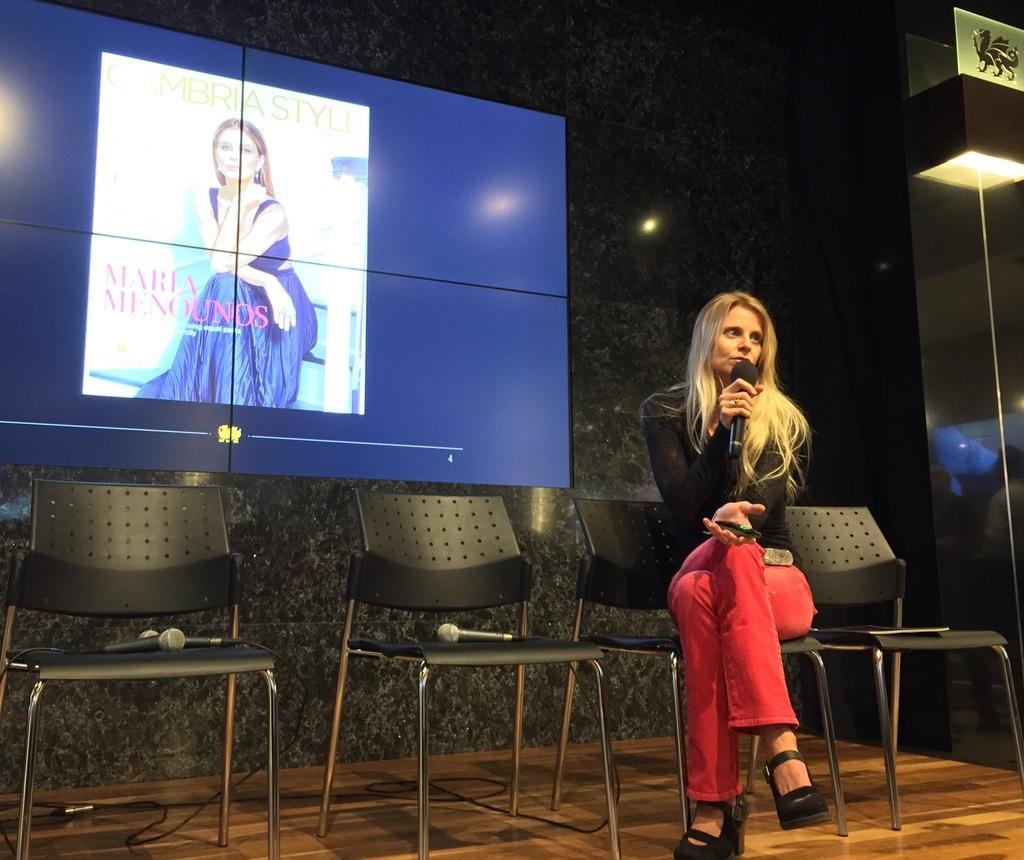Could you give a brief overview of what you see in this image? This picture shows a woman seated on the chairs and speaking with the help of a microphone and we see a screen on her back 